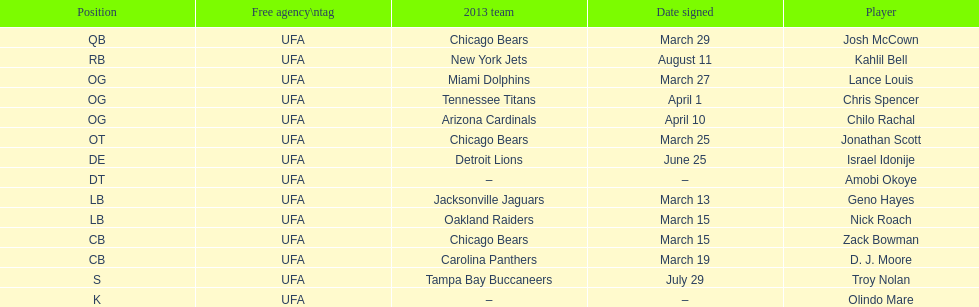Can you name the single player who signed in july? Troy Nolan. 